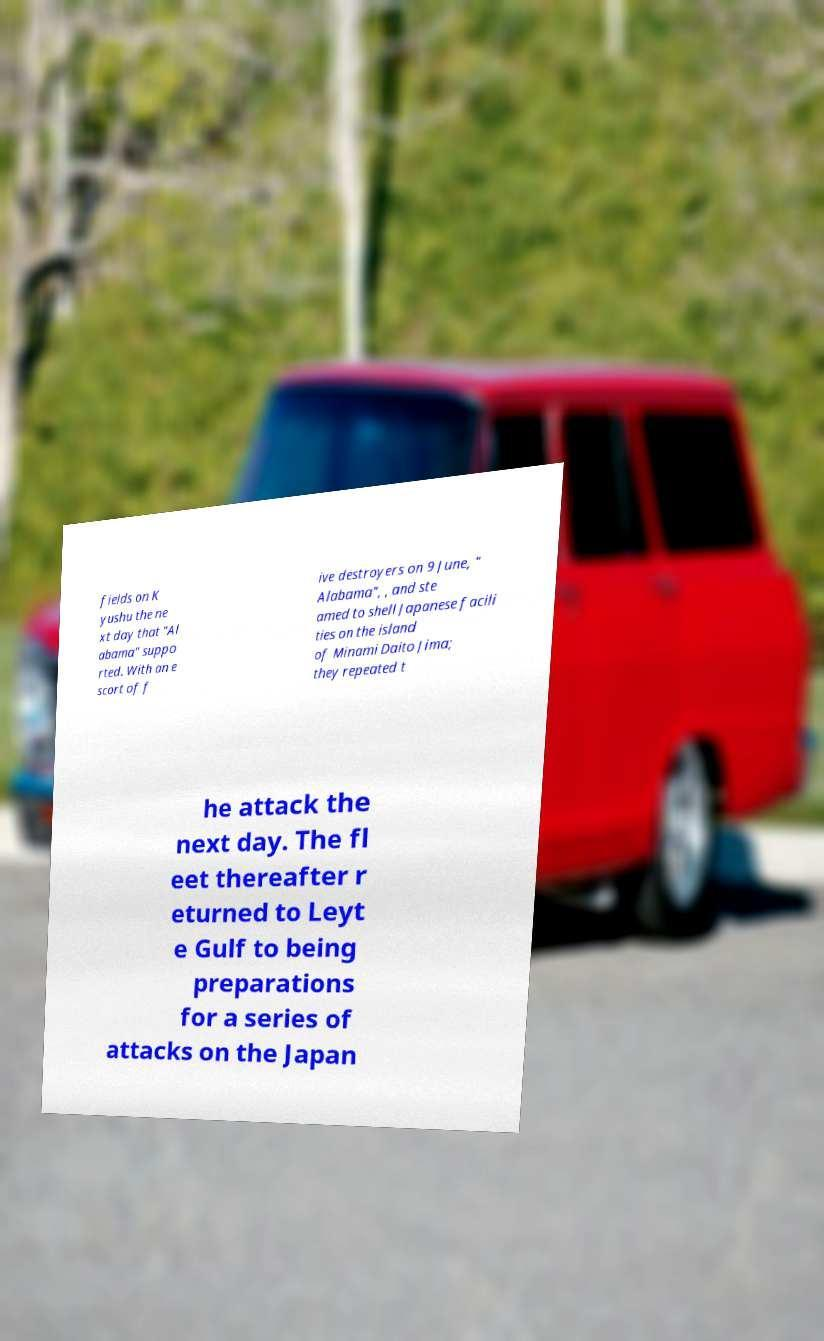Could you extract and type out the text from this image? fields on K yushu the ne xt day that "Al abama" suppo rted. With an e scort of f ive destroyers on 9 June, " Alabama", , and ste amed to shell Japanese facili ties on the island of Minami Daito Jima; they repeated t he attack the next day. The fl eet thereafter r eturned to Leyt e Gulf to being preparations for a series of attacks on the Japan 